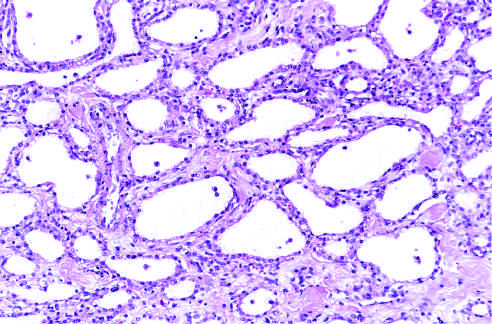re the cysts lined by cuboidal epithelium without atypia?
Answer the question using a single word or phrase. Yes 